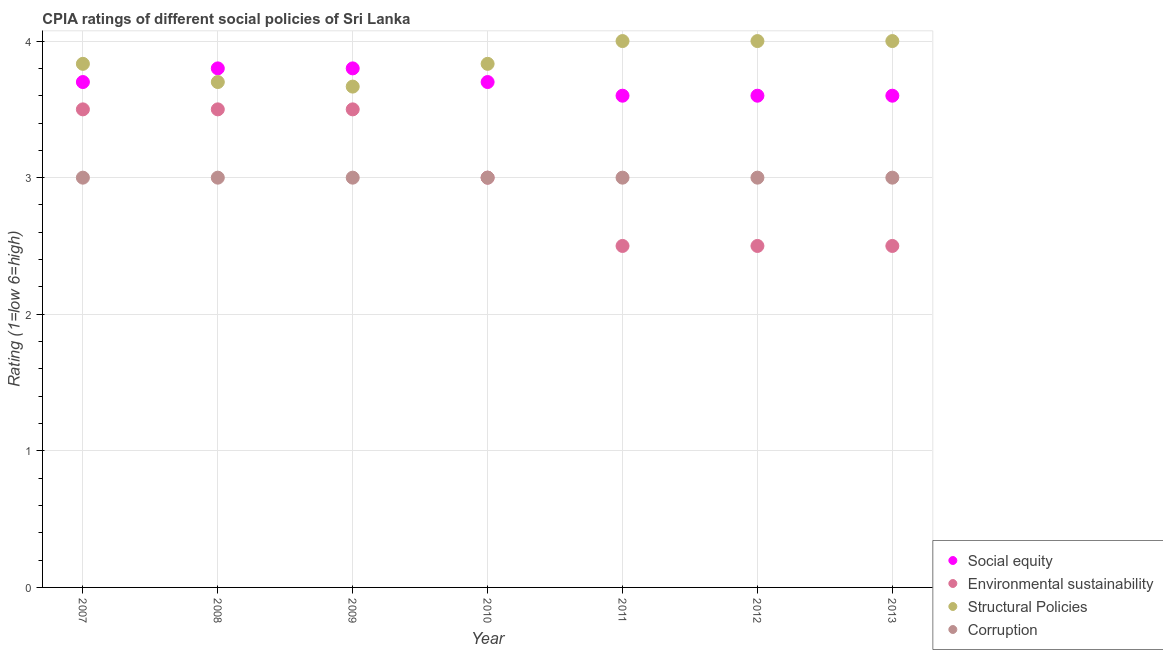How many different coloured dotlines are there?
Offer a very short reply. 4. What is the cpia rating of structural policies in 2009?
Keep it short and to the point. 3.67. Across all years, what is the maximum cpia rating of corruption?
Your answer should be compact. 3. Across all years, what is the minimum cpia rating of social equity?
Your answer should be very brief. 3.6. In which year was the cpia rating of corruption maximum?
Your answer should be compact. 2007. What is the total cpia rating of social equity in the graph?
Your answer should be very brief. 25.8. What is the difference between the cpia rating of environmental sustainability in 2008 and that in 2010?
Provide a short and direct response. 0.5. What is the average cpia rating of environmental sustainability per year?
Give a very brief answer. 3. In the year 2012, what is the difference between the cpia rating of corruption and cpia rating of environmental sustainability?
Make the answer very short. 0.5. What is the ratio of the cpia rating of social equity in 2009 to that in 2012?
Your response must be concise. 1.06. Is the difference between the cpia rating of environmental sustainability in 2007 and 2009 greater than the difference between the cpia rating of structural policies in 2007 and 2009?
Provide a short and direct response. No. What is the difference between the highest and the second highest cpia rating of social equity?
Your response must be concise. 0. What is the difference between the highest and the lowest cpia rating of structural policies?
Provide a succinct answer. 0.33. In how many years, is the cpia rating of environmental sustainability greater than the average cpia rating of environmental sustainability taken over all years?
Make the answer very short. 3. Is the sum of the cpia rating of environmental sustainability in 2007 and 2011 greater than the maximum cpia rating of social equity across all years?
Offer a very short reply. Yes. Is it the case that in every year, the sum of the cpia rating of social equity and cpia rating of environmental sustainability is greater than the cpia rating of structural policies?
Give a very brief answer. Yes. Is the cpia rating of environmental sustainability strictly greater than the cpia rating of structural policies over the years?
Provide a short and direct response. No. Is the cpia rating of corruption strictly less than the cpia rating of environmental sustainability over the years?
Your answer should be compact. No. How many years are there in the graph?
Your answer should be very brief. 7. Does the graph contain any zero values?
Keep it short and to the point. No. Where does the legend appear in the graph?
Your answer should be very brief. Bottom right. How many legend labels are there?
Your answer should be very brief. 4. How are the legend labels stacked?
Offer a very short reply. Vertical. What is the title of the graph?
Give a very brief answer. CPIA ratings of different social policies of Sri Lanka. Does "Oil" appear as one of the legend labels in the graph?
Give a very brief answer. No. What is the label or title of the Y-axis?
Offer a very short reply. Rating (1=low 6=high). What is the Rating (1=low 6=high) of Social equity in 2007?
Provide a short and direct response. 3.7. What is the Rating (1=low 6=high) of Structural Policies in 2007?
Give a very brief answer. 3.83. What is the Rating (1=low 6=high) in Corruption in 2007?
Your response must be concise. 3. What is the Rating (1=low 6=high) in Social equity in 2009?
Provide a short and direct response. 3.8. What is the Rating (1=low 6=high) of Environmental sustainability in 2009?
Ensure brevity in your answer.  3.5. What is the Rating (1=low 6=high) of Structural Policies in 2009?
Your answer should be compact. 3.67. What is the Rating (1=low 6=high) in Structural Policies in 2010?
Your response must be concise. 3.83. What is the Rating (1=low 6=high) in Social equity in 2011?
Your answer should be compact. 3.6. What is the Rating (1=low 6=high) of Environmental sustainability in 2011?
Offer a very short reply. 2.5. What is the Rating (1=low 6=high) of Corruption in 2011?
Provide a succinct answer. 3. What is the Rating (1=low 6=high) in Social equity in 2012?
Your answer should be compact. 3.6. What is the Rating (1=low 6=high) in Structural Policies in 2012?
Make the answer very short. 4. What is the Rating (1=low 6=high) in Environmental sustainability in 2013?
Your response must be concise. 2.5. Across all years, what is the maximum Rating (1=low 6=high) of Structural Policies?
Your response must be concise. 4. Across all years, what is the maximum Rating (1=low 6=high) in Corruption?
Ensure brevity in your answer.  3. Across all years, what is the minimum Rating (1=low 6=high) in Environmental sustainability?
Provide a succinct answer. 2.5. Across all years, what is the minimum Rating (1=low 6=high) in Structural Policies?
Keep it short and to the point. 3.67. What is the total Rating (1=low 6=high) of Social equity in the graph?
Provide a succinct answer. 25.8. What is the total Rating (1=low 6=high) of Structural Policies in the graph?
Your response must be concise. 27.03. What is the difference between the Rating (1=low 6=high) in Social equity in 2007 and that in 2008?
Your answer should be compact. -0.1. What is the difference between the Rating (1=low 6=high) of Environmental sustainability in 2007 and that in 2008?
Provide a succinct answer. 0. What is the difference between the Rating (1=low 6=high) in Structural Policies in 2007 and that in 2008?
Give a very brief answer. 0.13. What is the difference between the Rating (1=low 6=high) of Corruption in 2007 and that in 2008?
Your answer should be very brief. 0. What is the difference between the Rating (1=low 6=high) of Social equity in 2007 and that in 2009?
Offer a terse response. -0.1. What is the difference between the Rating (1=low 6=high) in Social equity in 2007 and that in 2010?
Your answer should be very brief. 0. What is the difference between the Rating (1=low 6=high) in Social equity in 2007 and that in 2011?
Ensure brevity in your answer.  0.1. What is the difference between the Rating (1=low 6=high) in Environmental sustainability in 2007 and that in 2011?
Your answer should be very brief. 1. What is the difference between the Rating (1=low 6=high) of Structural Policies in 2007 and that in 2011?
Provide a short and direct response. -0.17. What is the difference between the Rating (1=low 6=high) in Environmental sustainability in 2007 and that in 2012?
Your answer should be very brief. 1. What is the difference between the Rating (1=low 6=high) of Structural Policies in 2007 and that in 2012?
Offer a terse response. -0.17. What is the difference between the Rating (1=low 6=high) in Corruption in 2007 and that in 2012?
Ensure brevity in your answer.  0. What is the difference between the Rating (1=low 6=high) in Social equity in 2007 and that in 2013?
Offer a very short reply. 0.1. What is the difference between the Rating (1=low 6=high) of Corruption in 2007 and that in 2013?
Offer a terse response. 0. What is the difference between the Rating (1=low 6=high) in Social equity in 2008 and that in 2009?
Your answer should be very brief. 0. What is the difference between the Rating (1=low 6=high) of Environmental sustainability in 2008 and that in 2009?
Provide a succinct answer. 0. What is the difference between the Rating (1=low 6=high) in Structural Policies in 2008 and that in 2009?
Keep it short and to the point. 0.03. What is the difference between the Rating (1=low 6=high) of Social equity in 2008 and that in 2010?
Offer a very short reply. 0.1. What is the difference between the Rating (1=low 6=high) in Structural Policies in 2008 and that in 2010?
Offer a very short reply. -0.13. What is the difference between the Rating (1=low 6=high) in Corruption in 2008 and that in 2010?
Give a very brief answer. 0. What is the difference between the Rating (1=low 6=high) in Social equity in 2008 and that in 2011?
Ensure brevity in your answer.  0.2. What is the difference between the Rating (1=low 6=high) in Environmental sustainability in 2008 and that in 2011?
Your answer should be very brief. 1. What is the difference between the Rating (1=low 6=high) of Structural Policies in 2008 and that in 2011?
Your answer should be compact. -0.3. What is the difference between the Rating (1=low 6=high) of Corruption in 2008 and that in 2011?
Provide a succinct answer. 0. What is the difference between the Rating (1=low 6=high) of Environmental sustainability in 2008 and that in 2012?
Make the answer very short. 1. What is the difference between the Rating (1=low 6=high) in Corruption in 2008 and that in 2012?
Provide a succinct answer. 0. What is the difference between the Rating (1=low 6=high) in Environmental sustainability in 2008 and that in 2013?
Your answer should be very brief. 1. What is the difference between the Rating (1=low 6=high) of Corruption in 2008 and that in 2013?
Provide a short and direct response. 0. What is the difference between the Rating (1=low 6=high) of Social equity in 2009 and that in 2010?
Your answer should be compact. 0.1. What is the difference between the Rating (1=low 6=high) in Corruption in 2009 and that in 2010?
Offer a terse response. 0. What is the difference between the Rating (1=low 6=high) in Social equity in 2009 and that in 2011?
Make the answer very short. 0.2. What is the difference between the Rating (1=low 6=high) in Structural Policies in 2009 and that in 2011?
Your response must be concise. -0.33. What is the difference between the Rating (1=low 6=high) in Environmental sustainability in 2009 and that in 2012?
Your answer should be very brief. 1. What is the difference between the Rating (1=low 6=high) in Structural Policies in 2009 and that in 2012?
Your answer should be compact. -0.33. What is the difference between the Rating (1=low 6=high) in Corruption in 2009 and that in 2012?
Your answer should be compact. 0. What is the difference between the Rating (1=low 6=high) in Social equity in 2009 and that in 2013?
Keep it short and to the point. 0.2. What is the difference between the Rating (1=low 6=high) in Environmental sustainability in 2009 and that in 2013?
Your answer should be compact. 1. What is the difference between the Rating (1=low 6=high) of Structural Policies in 2009 and that in 2013?
Provide a succinct answer. -0.33. What is the difference between the Rating (1=low 6=high) in Social equity in 2010 and that in 2011?
Make the answer very short. 0.1. What is the difference between the Rating (1=low 6=high) of Structural Policies in 2010 and that in 2011?
Your answer should be compact. -0.17. What is the difference between the Rating (1=low 6=high) of Social equity in 2010 and that in 2012?
Keep it short and to the point. 0.1. What is the difference between the Rating (1=low 6=high) in Structural Policies in 2010 and that in 2012?
Your response must be concise. -0.17. What is the difference between the Rating (1=low 6=high) in Environmental sustainability in 2010 and that in 2013?
Offer a terse response. 0.5. What is the difference between the Rating (1=low 6=high) of Structural Policies in 2010 and that in 2013?
Provide a succinct answer. -0.17. What is the difference between the Rating (1=low 6=high) in Social equity in 2011 and that in 2012?
Offer a terse response. 0. What is the difference between the Rating (1=low 6=high) of Structural Policies in 2011 and that in 2012?
Your answer should be very brief. 0. What is the difference between the Rating (1=low 6=high) of Social equity in 2011 and that in 2013?
Provide a succinct answer. 0. What is the difference between the Rating (1=low 6=high) in Structural Policies in 2011 and that in 2013?
Provide a succinct answer. 0. What is the difference between the Rating (1=low 6=high) in Corruption in 2011 and that in 2013?
Provide a succinct answer. 0. What is the difference between the Rating (1=low 6=high) of Environmental sustainability in 2012 and that in 2013?
Make the answer very short. 0. What is the difference between the Rating (1=low 6=high) of Social equity in 2007 and the Rating (1=low 6=high) of Environmental sustainability in 2008?
Your response must be concise. 0.2. What is the difference between the Rating (1=low 6=high) in Social equity in 2007 and the Rating (1=low 6=high) in Structural Policies in 2008?
Ensure brevity in your answer.  0. What is the difference between the Rating (1=low 6=high) of Environmental sustainability in 2007 and the Rating (1=low 6=high) of Structural Policies in 2008?
Give a very brief answer. -0.2. What is the difference between the Rating (1=low 6=high) of Environmental sustainability in 2007 and the Rating (1=low 6=high) of Corruption in 2008?
Offer a terse response. 0.5. What is the difference between the Rating (1=low 6=high) in Structural Policies in 2007 and the Rating (1=low 6=high) in Corruption in 2008?
Ensure brevity in your answer.  0.83. What is the difference between the Rating (1=low 6=high) of Social equity in 2007 and the Rating (1=low 6=high) of Environmental sustainability in 2009?
Give a very brief answer. 0.2. What is the difference between the Rating (1=low 6=high) of Social equity in 2007 and the Rating (1=low 6=high) of Corruption in 2009?
Give a very brief answer. 0.7. What is the difference between the Rating (1=low 6=high) of Social equity in 2007 and the Rating (1=low 6=high) of Structural Policies in 2010?
Provide a short and direct response. -0.13. What is the difference between the Rating (1=low 6=high) in Social equity in 2007 and the Rating (1=low 6=high) in Corruption in 2010?
Your response must be concise. 0.7. What is the difference between the Rating (1=low 6=high) of Environmental sustainability in 2007 and the Rating (1=low 6=high) of Structural Policies in 2010?
Provide a succinct answer. -0.33. What is the difference between the Rating (1=low 6=high) of Environmental sustainability in 2007 and the Rating (1=low 6=high) of Corruption in 2010?
Give a very brief answer. 0.5. What is the difference between the Rating (1=low 6=high) of Structural Policies in 2007 and the Rating (1=low 6=high) of Corruption in 2010?
Your answer should be very brief. 0.83. What is the difference between the Rating (1=low 6=high) in Social equity in 2007 and the Rating (1=low 6=high) in Structural Policies in 2011?
Give a very brief answer. -0.3. What is the difference between the Rating (1=low 6=high) in Environmental sustainability in 2007 and the Rating (1=low 6=high) in Structural Policies in 2011?
Provide a short and direct response. -0.5. What is the difference between the Rating (1=low 6=high) in Environmental sustainability in 2007 and the Rating (1=low 6=high) in Corruption in 2011?
Provide a succinct answer. 0.5. What is the difference between the Rating (1=low 6=high) of Structural Policies in 2007 and the Rating (1=low 6=high) of Corruption in 2011?
Keep it short and to the point. 0.83. What is the difference between the Rating (1=low 6=high) in Social equity in 2007 and the Rating (1=low 6=high) in Environmental sustainability in 2012?
Your response must be concise. 1.2. What is the difference between the Rating (1=low 6=high) in Social equity in 2007 and the Rating (1=low 6=high) in Structural Policies in 2012?
Provide a succinct answer. -0.3. What is the difference between the Rating (1=low 6=high) in Social equity in 2007 and the Rating (1=low 6=high) in Corruption in 2012?
Give a very brief answer. 0.7. What is the difference between the Rating (1=low 6=high) of Environmental sustainability in 2007 and the Rating (1=low 6=high) of Corruption in 2012?
Make the answer very short. 0.5. What is the difference between the Rating (1=low 6=high) of Social equity in 2007 and the Rating (1=low 6=high) of Environmental sustainability in 2013?
Provide a succinct answer. 1.2. What is the difference between the Rating (1=low 6=high) in Social equity in 2007 and the Rating (1=low 6=high) in Corruption in 2013?
Provide a short and direct response. 0.7. What is the difference between the Rating (1=low 6=high) of Environmental sustainability in 2007 and the Rating (1=low 6=high) of Structural Policies in 2013?
Provide a succinct answer. -0.5. What is the difference between the Rating (1=low 6=high) of Structural Policies in 2007 and the Rating (1=low 6=high) of Corruption in 2013?
Offer a terse response. 0.83. What is the difference between the Rating (1=low 6=high) of Social equity in 2008 and the Rating (1=low 6=high) of Structural Policies in 2009?
Your answer should be compact. 0.13. What is the difference between the Rating (1=low 6=high) in Environmental sustainability in 2008 and the Rating (1=low 6=high) in Corruption in 2009?
Offer a terse response. 0.5. What is the difference between the Rating (1=low 6=high) in Structural Policies in 2008 and the Rating (1=low 6=high) in Corruption in 2009?
Keep it short and to the point. 0.7. What is the difference between the Rating (1=low 6=high) of Social equity in 2008 and the Rating (1=low 6=high) of Environmental sustainability in 2010?
Your response must be concise. 0.8. What is the difference between the Rating (1=low 6=high) in Social equity in 2008 and the Rating (1=low 6=high) in Structural Policies in 2010?
Ensure brevity in your answer.  -0.03. What is the difference between the Rating (1=low 6=high) of Social equity in 2008 and the Rating (1=low 6=high) of Corruption in 2010?
Your answer should be very brief. 0.8. What is the difference between the Rating (1=low 6=high) in Environmental sustainability in 2008 and the Rating (1=low 6=high) in Structural Policies in 2010?
Provide a succinct answer. -0.33. What is the difference between the Rating (1=low 6=high) of Environmental sustainability in 2008 and the Rating (1=low 6=high) of Corruption in 2010?
Your answer should be compact. 0.5. What is the difference between the Rating (1=low 6=high) of Social equity in 2008 and the Rating (1=low 6=high) of Environmental sustainability in 2011?
Your answer should be compact. 1.3. What is the difference between the Rating (1=low 6=high) of Social equity in 2008 and the Rating (1=low 6=high) of Structural Policies in 2011?
Give a very brief answer. -0.2. What is the difference between the Rating (1=low 6=high) of Social equity in 2008 and the Rating (1=low 6=high) of Corruption in 2011?
Keep it short and to the point. 0.8. What is the difference between the Rating (1=low 6=high) in Environmental sustainability in 2008 and the Rating (1=low 6=high) in Structural Policies in 2011?
Keep it short and to the point. -0.5. What is the difference between the Rating (1=low 6=high) of Environmental sustainability in 2008 and the Rating (1=low 6=high) of Structural Policies in 2012?
Give a very brief answer. -0.5. What is the difference between the Rating (1=low 6=high) in Structural Policies in 2008 and the Rating (1=low 6=high) in Corruption in 2012?
Ensure brevity in your answer.  0.7. What is the difference between the Rating (1=low 6=high) of Environmental sustainability in 2008 and the Rating (1=low 6=high) of Structural Policies in 2013?
Give a very brief answer. -0.5. What is the difference between the Rating (1=low 6=high) of Environmental sustainability in 2008 and the Rating (1=low 6=high) of Corruption in 2013?
Give a very brief answer. 0.5. What is the difference between the Rating (1=low 6=high) of Social equity in 2009 and the Rating (1=low 6=high) of Environmental sustainability in 2010?
Your answer should be compact. 0.8. What is the difference between the Rating (1=low 6=high) of Social equity in 2009 and the Rating (1=low 6=high) of Structural Policies in 2010?
Your answer should be very brief. -0.03. What is the difference between the Rating (1=low 6=high) in Social equity in 2009 and the Rating (1=low 6=high) in Corruption in 2010?
Ensure brevity in your answer.  0.8. What is the difference between the Rating (1=low 6=high) of Environmental sustainability in 2009 and the Rating (1=low 6=high) of Corruption in 2010?
Provide a short and direct response. 0.5. What is the difference between the Rating (1=low 6=high) in Structural Policies in 2009 and the Rating (1=low 6=high) in Corruption in 2010?
Ensure brevity in your answer.  0.67. What is the difference between the Rating (1=low 6=high) of Social equity in 2009 and the Rating (1=low 6=high) of Environmental sustainability in 2011?
Give a very brief answer. 1.3. What is the difference between the Rating (1=low 6=high) in Social equity in 2009 and the Rating (1=low 6=high) in Structural Policies in 2011?
Provide a short and direct response. -0.2. What is the difference between the Rating (1=low 6=high) in Social equity in 2009 and the Rating (1=low 6=high) in Corruption in 2011?
Offer a terse response. 0.8. What is the difference between the Rating (1=low 6=high) of Environmental sustainability in 2009 and the Rating (1=low 6=high) of Structural Policies in 2011?
Offer a terse response. -0.5. What is the difference between the Rating (1=low 6=high) of Environmental sustainability in 2009 and the Rating (1=low 6=high) of Corruption in 2011?
Provide a short and direct response. 0.5. What is the difference between the Rating (1=low 6=high) of Social equity in 2009 and the Rating (1=low 6=high) of Environmental sustainability in 2012?
Offer a very short reply. 1.3. What is the difference between the Rating (1=low 6=high) of Environmental sustainability in 2009 and the Rating (1=low 6=high) of Corruption in 2012?
Your answer should be very brief. 0.5. What is the difference between the Rating (1=low 6=high) of Structural Policies in 2009 and the Rating (1=low 6=high) of Corruption in 2012?
Keep it short and to the point. 0.67. What is the difference between the Rating (1=low 6=high) of Social equity in 2009 and the Rating (1=low 6=high) of Corruption in 2013?
Make the answer very short. 0.8. What is the difference between the Rating (1=low 6=high) of Social equity in 2010 and the Rating (1=low 6=high) of Environmental sustainability in 2011?
Keep it short and to the point. 1.2. What is the difference between the Rating (1=low 6=high) of Social equity in 2010 and the Rating (1=low 6=high) of Corruption in 2011?
Keep it short and to the point. 0.7. What is the difference between the Rating (1=low 6=high) of Environmental sustainability in 2010 and the Rating (1=low 6=high) of Corruption in 2011?
Your answer should be compact. 0. What is the difference between the Rating (1=low 6=high) in Structural Policies in 2010 and the Rating (1=low 6=high) in Corruption in 2011?
Offer a very short reply. 0.83. What is the difference between the Rating (1=low 6=high) of Social equity in 2010 and the Rating (1=low 6=high) of Environmental sustainability in 2012?
Provide a short and direct response. 1.2. What is the difference between the Rating (1=low 6=high) in Social equity in 2010 and the Rating (1=low 6=high) in Structural Policies in 2012?
Your answer should be very brief. -0.3. What is the difference between the Rating (1=low 6=high) of Social equity in 2010 and the Rating (1=low 6=high) of Corruption in 2012?
Provide a succinct answer. 0.7. What is the difference between the Rating (1=low 6=high) in Structural Policies in 2010 and the Rating (1=low 6=high) in Corruption in 2012?
Ensure brevity in your answer.  0.83. What is the difference between the Rating (1=low 6=high) of Social equity in 2010 and the Rating (1=low 6=high) of Environmental sustainability in 2013?
Provide a short and direct response. 1.2. What is the difference between the Rating (1=low 6=high) of Environmental sustainability in 2010 and the Rating (1=low 6=high) of Structural Policies in 2013?
Provide a short and direct response. -1. What is the difference between the Rating (1=low 6=high) of Structural Policies in 2010 and the Rating (1=low 6=high) of Corruption in 2013?
Provide a succinct answer. 0.83. What is the difference between the Rating (1=low 6=high) of Social equity in 2011 and the Rating (1=low 6=high) of Environmental sustainability in 2012?
Offer a very short reply. 1.1. What is the difference between the Rating (1=low 6=high) in Social equity in 2011 and the Rating (1=low 6=high) in Structural Policies in 2012?
Offer a terse response. -0.4. What is the difference between the Rating (1=low 6=high) in Environmental sustainability in 2011 and the Rating (1=low 6=high) in Structural Policies in 2012?
Your answer should be very brief. -1.5. What is the difference between the Rating (1=low 6=high) of Environmental sustainability in 2011 and the Rating (1=low 6=high) of Corruption in 2012?
Ensure brevity in your answer.  -0.5. What is the difference between the Rating (1=low 6=high) of Environmental sustainability in 2011 and the Rating (1=low 6=high) of Structural Policies in 2013?
Provide a short and direct response. -1.5. What is the difference between the Rating (1=low 6=high) of Social equity in 2012 and the Rating (1=low 6=high) of Environmental sustainability in 2013?
Offer a terse response. 1.1. What is the difference between the Rating (1=low 6=high) of Environmental sustainability in 2012 and the Rating (1=low 6=high) of Corruption in 2013?
Make the answer very short. -0.5. What is the average Rating (1=low 6=high) in Social equity per year?
Your answer should be compact. 3.69. What is the average Rating (1=low 6=high) of Structural Policies per year?
Your response must be concise. 3.86. What is the average Rating (1=low 6=high) in Corruption per year?
Provide a short and direct response. 3. In the year 2007, what is the difference between the Rating (1=low 6=high) in Social equity and Rating (1=low 6=high) in Environmental sustainability?
Provide a short and direct response. 0.2. In the year 2007, what is the difference between the Rating (1=low 6=high) of Social equity and Rating (1=low 6=high) of Structural Policies?
Give a very brief answer. -0.13. In the year 2007, what is the difference between the Rating (1=low 6=high) of Social equity and Rating (1=low 6=high) of Corruption?
Your answer should be compact. 0.7. In the year 2007, what is the difference between the Rating (1=low 6=high) in Environmental sustainability and Rating (1=low 6=high) in Structural Policies?
Your answer should be very brief. -0.33. In the year 2007, what is the difference between the Rating (1=low 6=high) of Environmental sustainability and Rating (1=low 6=high) of Corruption?
Ensure brevity in your answer.  0.5. In the year 2008, what is the difference between the Rating (1=low 6=high) of Social equity and Rating (1=low 6=high) of Environmental sustainability?
Provide a succinct answer. 0.3. In the year 2008, what is the difference between the Rating (1=low 6=high) in Social equity and Rating (1=low 6=high) in Structural Policies?
Provide a succinct answer. 0.1. In the year 2008, what is the difference between the Rating (1=low 6=high) in Social equity and Rating (1=low 6=high) in Corruption?
Your answer should be very brief. 0.8. In the year 2008, what is the difference between the Rating (1=low 6=high) in Structural Policies and Rating (1=low 6=high) in Corruption?
Give a very brief answer. 0.7. In the year 2009, what is the difference between the Rating (1=low 6=high) in Social equity and Rating (1=low 6=high) in Structural Policies?
Keep it short and to the point. 0.13. In the year 2009, what is the difference between the Rating (1=low 6=high) of Social equity and Rating (1=low 6=high) of Corruption?
Make the answer very short. 0.8. In the year 2009, what is the difference between the Rating (1=low 6=high) in Environmental sustainability and Rating (1=low 6=high) in Corruption?
Offer a very short reply. 0.5. In the year 2009, what is the difference between the Rating (1=low 6=high) of Structural Policies and Rating (1=low 6=high) of Corruption?
Your answer should be very brief. 0.67. In the year 2010, what is the difference between the Rating (1=low 6=high) in Social equity and Rating (1=low 6=high) in Environmental sustainability?
Provide a short and direct response. 0.7. In the year 2010, what is the difference between the Rating (1=low 6=high) in Social equity and Rating (1=low 6=high) in Structural Policies?
Offer a very short reply. -0.13. In the year 2010, what is the difference between the Rating (1=low 6=high) of Social equity and Rating (1=low 6=high) of Corruption?
Offer a very short reply. 0.7. In the year 2010, what is the difference between the Rating (1=low 6=high) of Environmental sustainability and Rating (1=low 6=high) of Structural Policies?
Provide a succinct answer. -0.83. In the year 2010, what is the difference between the Rating (1=low 6=high) of Structural Policies and Rating (1=low 6=high) of Corruption?
Your response must be concise. 0.83. In the year 2011, what is the difference between the Rating (1=low 6=high) of Social equity and Rating (1=low 6=high) of Structural Policies?
Offer a terse response. -0.4. In the year 2011, what is the difference between the Rating (1=low 6=high) in Social equity and Rating (1=low 6=high) in Corruption?
Ensure brevity in your answer.  0.6. In the year 2011, what is the difference between the Rating (1=low 6=high) in Environmental sustainability and Rating (1=low 6=high) in Structural Policies?
Keep it short and to the point. -1.5. In the year 2011, what is the difference between the Rating (1=low 6=high) in Environmental sustainability and Rating (1=low 6=high) in Corruption?
Make the answer very short. -0.5. In the year 2011, what is the difference between the Rating (1=low 6=high) of Structural Policies and Rating (1=low 6=high) of Corruption?
Ensure brevity in your answer.  1. In the year 2012, what is the difference between the Rating (1=low 6=high) of Social equity and Rating (1=low 6=high) of Structural Policies?
Your response must be concise. -0.4. In the year 2012, what is the difference between the Rating (1=low 6=high) of Environmental sustainability and Rating (1=low 6=high) of Structural Policies?
Offer a very short reply. -1.5. In the year 2013, what is the difference between the Rating (1=low 6=high) in Social equity and Rating (1=low 6=high) in Environmental sustainability?
Provide a succinct answer. 1.1. In the year 2013, what is the difference between the Rating (1=low 6=high) of Social equity and Rating (1=low 6=high) of Corruption?
Offer a terse response. 0.6. In the year 2013, what is the difference between the Rating (1=low 6=high) in Environmental sustainability and Rating (1=low 6=high) in Structural Policies?
Offer a very short reply. -1.5. What is the ratio of the Rating (1=low 6=high) of Social equity in 2007 to that in 2008?
Your answer should be compact. 0.97. What is the ratio of the Rating (1=low 6=high) of Structural Policies in 2007 to that in 2008?
Your response must be concise. 1.04. What is the ratio of the Rating (1=low 6=high) of Social equity in 2007 to that in 2009?
Make the answer very short. 0.97. What is the ratio of the Rating (1=low 6=high) of Environmental sustainability in 2007 to that in 2009?
Offer a very short reply. 1. What is the ratio of the Rating (1=low 6=high) in Structural Policies in 2007 to that in 2009?
Your answer should be very brief. 1.05. What is the ratio of the Rating (1=low 6=high) of Corruption in 2007 to that in 2009?
Provide a short and direct response. 1. What is the ratio of the Rating (1=low 6=high) of Corruption in 2007 to that in 2010?
Provide a short and direct response. 1. What is the ratio of the Rating (1=low 6=high) in Social equity in 2007 to that in 2011?
Your response must be concise. 1.03. What is the ratio of the Rating (1=low 6=high) in Structural Policies in 2007 to that in 2011?
Offer a very short reply. 0.96. What is the ratio of the Rating (1=low 6=high) of Corruption in 2007 to that in 2011?
Your response must be concise. 1. What is the ratio of the Rating (1=low 6=high) of Social equity in 2007 to that in 2012?
Make the answer very short. 1.03. What is the ratio of the Rating (1=low 6=high) of Social equity in 2007 to that in 2013?
Offer a terse response. 1.03. What is the ratio of the Rating (1=low 6=high) of Structural Policies in 2007 to that in 2013?
Ensure brevity in your answer.  0.96. What is the ratio of the Rating (1=low 6=high) of Social equity in 2008 to that in 2009?
Offer a very short reply. 1. What is the ratio of the Rating (1=low 6=high) in Structural Policies in 2008 to that in 2009?
Offer a very short reply. 1.01. What is the ratio of the Rating (1=low 6=high) in Environmental sustainability in 2008 to that in 2010?
Give a very brief answer. 1.17. What is the ratio of the Rating (1=low 6=high) of Structural Policies in 2008 to that in 2010?
Offer a terse response. 0.97. What is the ratio of the Rating (1=low 6=high) in Social equity in 2008 to that in 2011?
Ensure brevity in your answer.  1.06. What is the ratio of the Rating (1=low 6=high) of Environmental sustainability in 2008 to that in 2011?
Your answer should be very brief. 1.4. What is the ratio of the Rating (1=low 6=high) in Structural Policies in 2008 to that in 2011?
Provide a succinct answer. 0.93. What is the ratio of the Rating (1=low 6=high) of Social equity in 2008 to that in 2012?
Your answer should be very brief. 1.06. What is the ratio of the Rating (1=low 6=high) in Environmental sustainability in 2008 to that in 2012?
Offer a terse response. 1.4. What is the ratio of the Rating (1=low 6=high) in Structural Policies in 2008 to that in 2012?
Offer a very short reply. 0.93. What is the ratio of the Rating (1=low 6=high) in Corruption in 2008 to that in 2012?
Make the answer very short. 1. What is the ratio of the Rating (1=low 6=high) in Social equity in 2008 to that in 2013?
Keep it short and to the point. 1.06. What is the ratio of the Rating (1=low 6=high) in Environmental sustainability in 2008 to that in 2013?
Make the answer very short. 1.4. What is the ratio of the Rating (1=low 6=high) of Structural Policies in 2008 to that in 2013?
Give a very brief answer. 0.93. What is the ratio of the Rating (1=low 6=high) of Environmental sustainability in 2009 to that in 2010?
Your response must be concise. 1.17. What is the ratio of the Rating (1=low 6=high) in Structural Policies in 2009 to that in 2010?
Make the answer very short. 0.96. What is the ratio of the Rating (1=low 6=high) of Social equity in 2009 to that in 2011?
Ensure brevity in your answer.  1.06. What is the ratio of the Rating (1=low 6=high) in Environmental sustainability in 2009 to that in 2011?
Keep it short and to the point. 1.4. What is the ratio of the Rating (1=low 6=high) of Structural Policies in 2009 to that in 2011?
Your answer should be very brief. 0.92. What is the ratio of the Rating (1=low 6=high) of Corruption in 2009 to that in 2011?
Offer a very short reply. 1. What is the ratio of the Rating (1=low 6=high) in Social equity in 2009 to that in 2012?
Offer a very short reply. 1.06. What is the ratio of the Rating (1=low 6=high) in Corruption in 2009 to that in 2012?
Give a very brief answer. 1. What is the ratio of the Rating (1=low 6=high) of Social equity in 2009 to that in 2013?
Provide a short and direct response. 1.06. What is the ratio of the Rating (1=low 6=high) of Social equity in 2010 to that in 2011?
Provide a short and direct response. 1.03. What is the ratio of the Rating (1=low 6=high) in Environmental sustainability in 2010 to that in 2011?
Offer a very short reply. 1.2. What is the ratio of the Rating (1=low 6=high) of Structural Policies in 2010 to that in 2011?
Offer a very short reply. 0.96. What is the ratio of the Rating (1=low 6=high) in Social equity in 2010 to that in 2012?
Your answer should be very brief. 1.03. What is the ratio of the Rating (1=low 6=high) of Environmental sustainability in 2010 to that in 2012?
Make the answer very short. 1.2. What is the ratio of the Rating (1=low 6=high) in Structural Policies in 2010 to that in 2012?
Offer a terse response. 0.96. What is the ratio of the Rating (1=low 6=high) of Social equity in 2010 to that in 2013?
Offer a very short reply. 1.03. What is the ratio of the Rating (1=low 6=high) in Environmental sustainability in 2010 to that in 2013?
Give a very brief answer. 1.2. What is the ratio of the Rating (1=low 6=high) of Structural Policies in 2010 to that in 2013?
Offer a very short reply. 0.96. What is the ratio of the Rating (1=low 6=high) of Environmental sustainability in 2011 to that in 2012?
Provide a short and direct response. 1. What is the ratio of the Rating (1=low 6=high) of Corruption in 2011 to that in 2012?
Your answer should be very brief. 1. What is the ratio of the Rating (1=low 6=high) in Social equity in 2011 to that in 2013?
Your answer should be very brief. 1. What is the ratio of the Rating (1=low 6=high) of Environmental sustainability in 2011 to that in 2013?
Ensure brevity in your answer.  1. What is the ratio of the Rating (1=low 6=high) of Structural Policies in 2011 to that in 2013?
Your answer should be compact. 1. What is the ratio of the Rating (1=low 6=high) of Social equity in 2012 to that in 2013?
Ensure brevity in your answer.  1. What is the ratio of the Rating (1=low 6=high) of Environmental sustainability in 2012 to that in 2013?
Offer a terse response. 1. What is the ratio of the Rating (1=low 6=high) of Corruption in 2012 to that in 2013?
Ensure brevity in your answer.  1. What is the difference between the highest and the second highest Rating (1=low 6=high) of Structural Policies?
Give a very brief answer. 0. What is the difference between the highest and the second highest Rating (1=low 6=high) of Corruption?
Offer a very short reply. 0. What is the difference between the highest and the lowest Rating (1=low 6=high) of Corruption?
Ensure brevity in your answer.  0. 